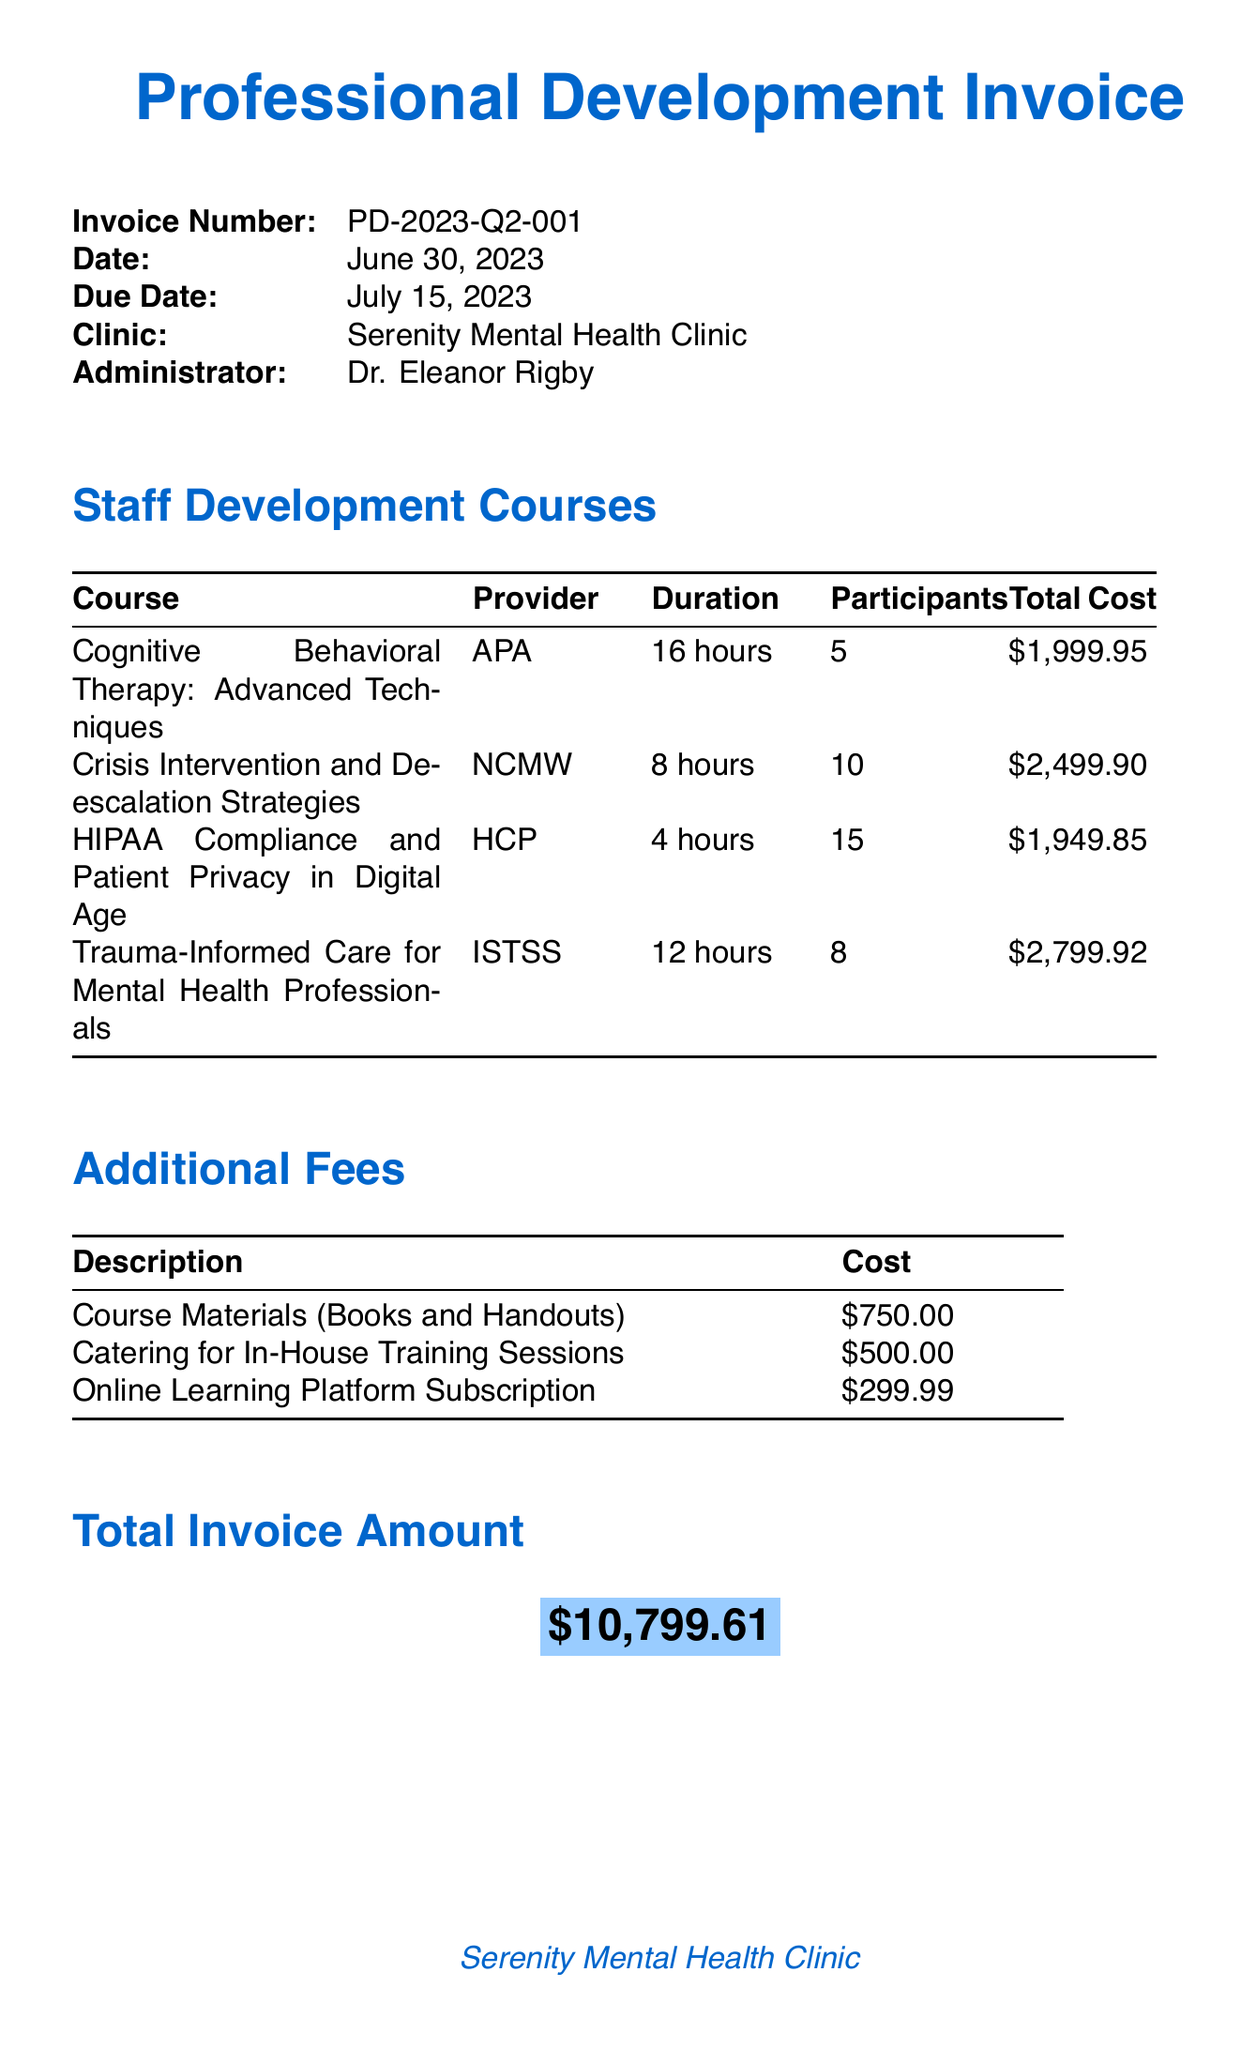what is the invoice number? The invoice number is explicitly stated in the document as a unique identifier for the invoice.
Answer: PD-2023-Q2-001 what is the due date for the invoice? The due date is specified in the document, indicating when the payment should be made.
Answer: July 15, 2023 how many total hours does the "Crisis Intervention and De-escalation Strategies" course last? The duration of this specific course is mentioned in the document under the course details.
Answer: 8 hours what is the total cost for the "HIPAA Compliance and Patient Privacy in Digital Age" course? The document provides the total cost, giving the amount charged for this course.
Answer: 1949.85 how many participants attended the "Trauma-Informed Care for Mental Health Professionals" course? The number of participants is listed in the course details within the document.
Answer: 8 what is the total invoice amount? The document clearly states the total invoice amount, which sums up all costs.
Answer: 10799.61 what is the payment method mentioned in the invoice? The document specifies how the payment should be made for the invoice.
Answer: Bank Transfer what is one of the administrator notes for the staff members regarding course completion? The notes include specific requirements related to staff responsibilities for course completion outlined in the document.
Answer: All staff members are required to complete their assigned courses within 30 days of the invoice date how much is charged for course materials? The document specifies the cost associated with course materials as an additional fee.
Answer: 750.00 